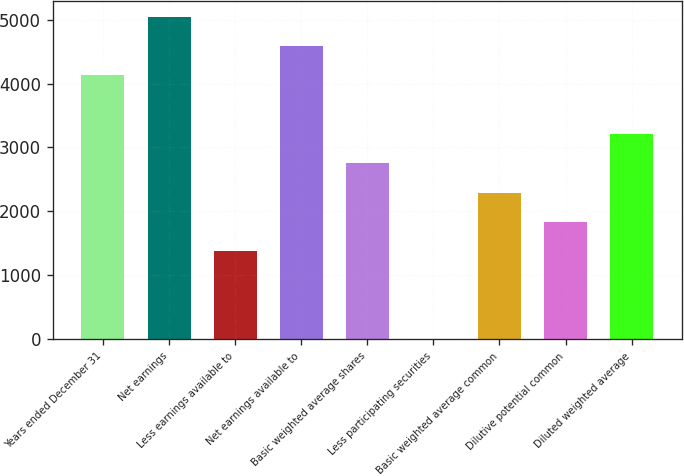Convert chart to OTSL. <chart><loc_0><loc_0><loc_500><loc_500><bar_chart><fcel>Years ended December 31<fcel>Net earnings<fcel>Less earnings available to<fcel>Net earnings available to<fcel>Basic weighted average shares<fcel>Less participating securities<fcel>Basic weighted average common<fcel>Dilutive potential common<fcel>Diluted weighted average<nl><fcel>4126.69<fcel>5043.31<fcel>1376.83<fcel>4585<fcel>2751.76<fcel>1.9<fcel>2293.45<fcel>1835.14<fcel>3210.07<nl></chart> 